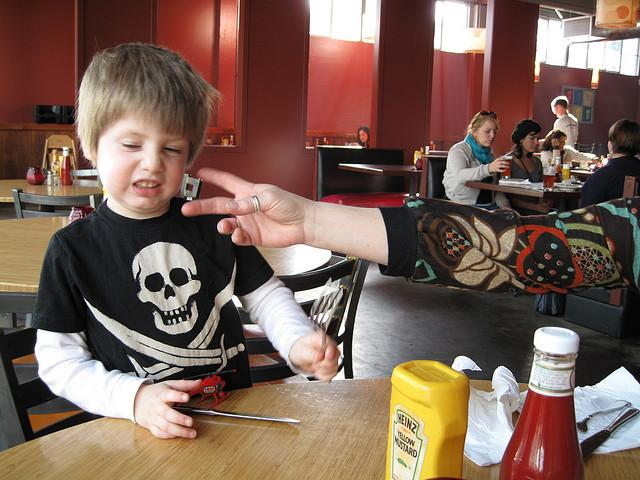Where is the table the boy is sitting at? Please explain your reasoning. restaurant. You can tell by the tables and other customers around that it is. 